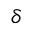<formula> <loc_0><loc_0><loc_500><loc_500>\delta</formula> 